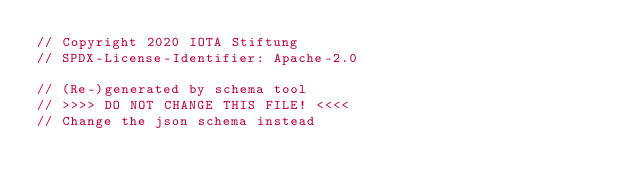Convert code to text. <code><loc_0><loc_0><loc_500><loc_500><_Rust_>// Copyright 2020 IOTA Stiftung
// SPDX-License-Identifier: Apache-2.0

// (Re-)generated by schema tool
// >>>> DO NOT CHANGE THIS FILE! <<<<
// Change the json schema instead
</code> 